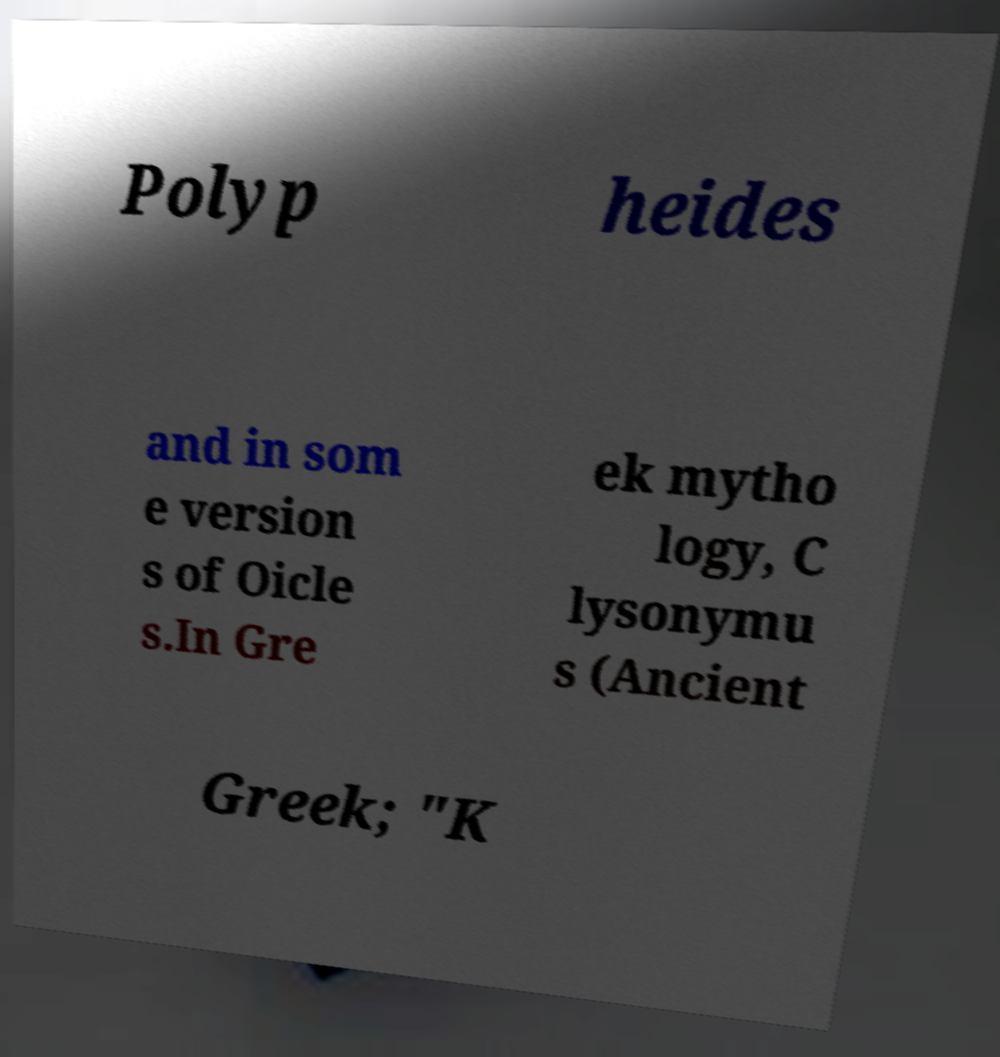Please read and relay the text visible in this image. What does it say? Polyp heides and in som e version s of Oicle s.In Gre ek mytho logy, C lysonymu s (Ancient Greek; "K 